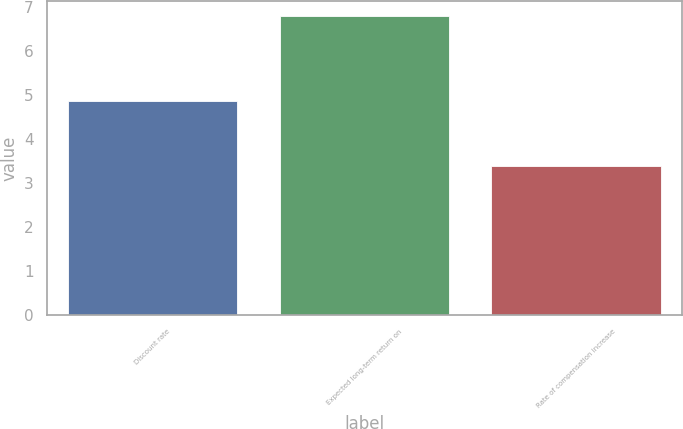<chart> <loc_0><loc_0><loc_500><loc_500><bar_chart><fcel>Discount rate<fcel>Expected long-term return on<fcel>Rate of compensation increase<nl><fcel>4.86<fcel>6.8<fcel>3.39<nl></chart> 